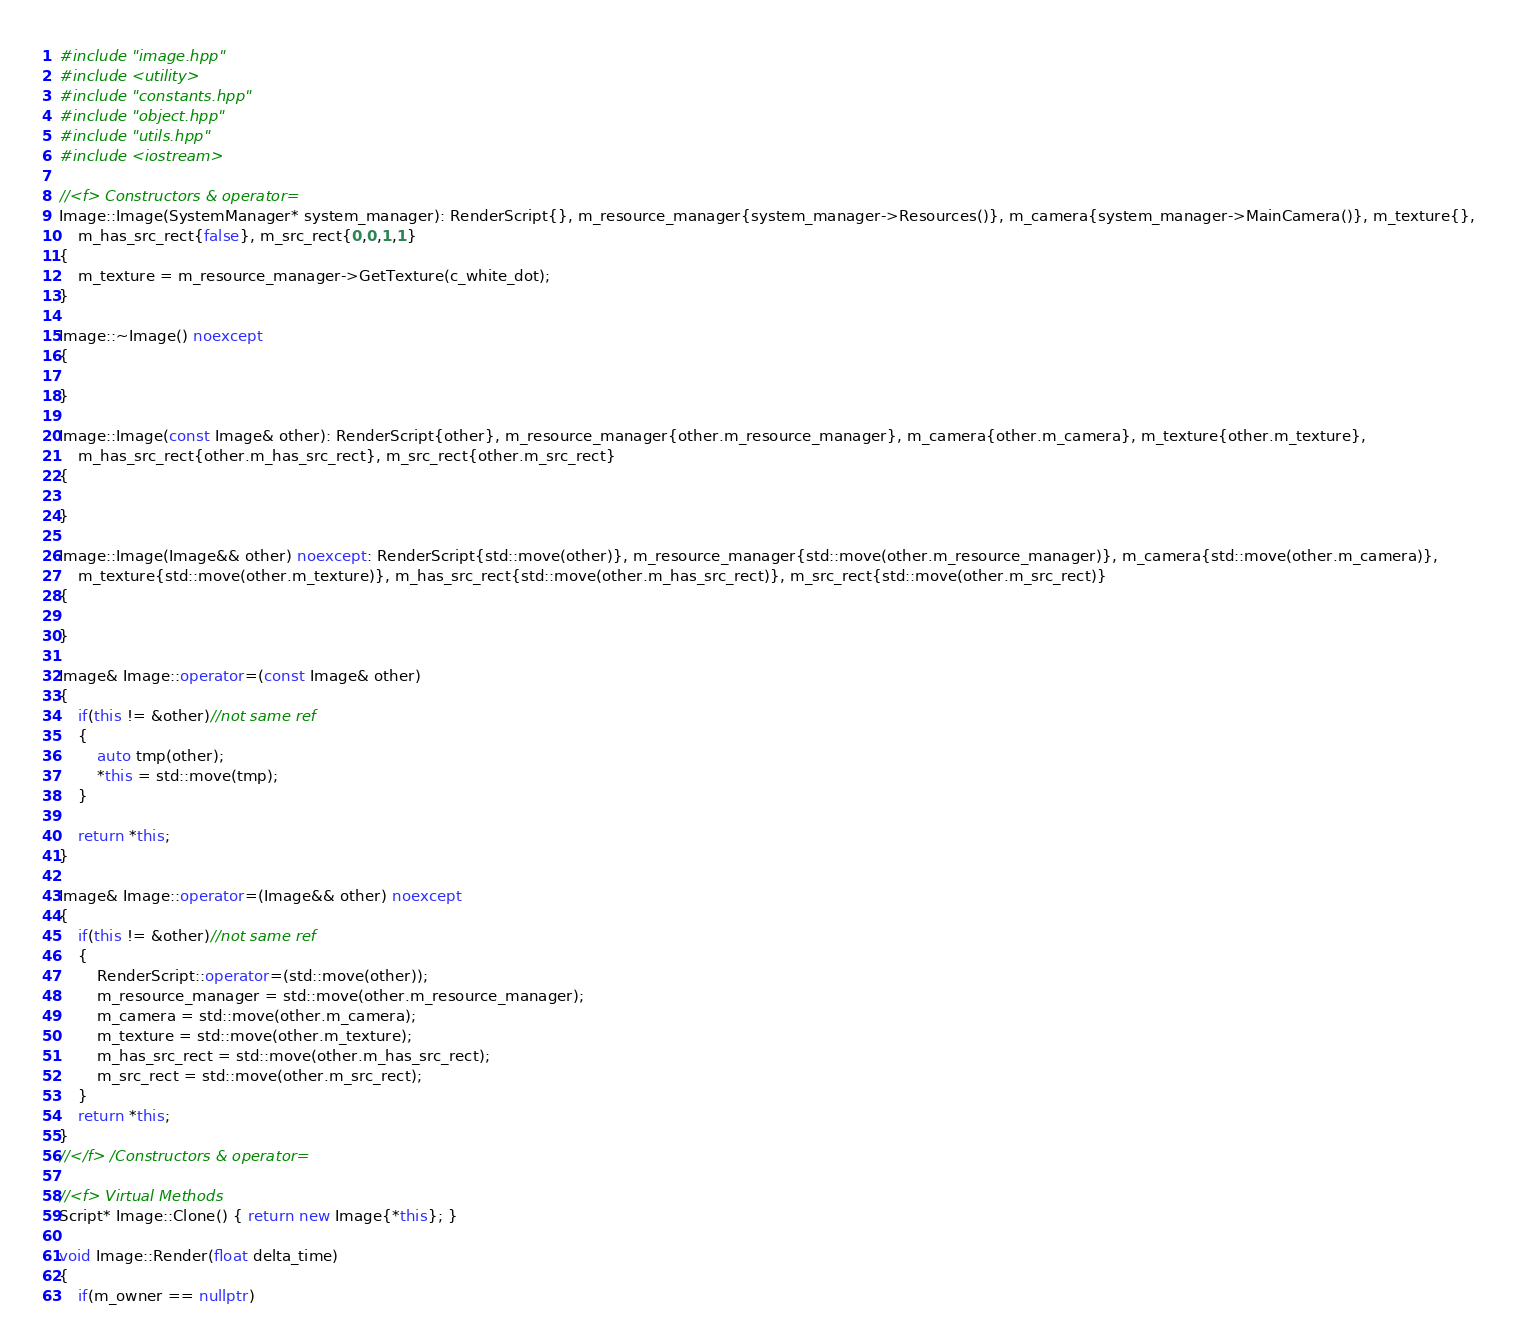Convert code to text. <code><loc_0><loc_0><loc_500><loc_500><_C++_>#include "image.hpp"
#include <utility>
#include "constants.hpp"
#include "object.hpp"
#include "utils.hpp"
#include <iostream>

//<f> Constructors & operator=
Image::Image(SystemManager* system_manager): RenderScript{}, m_resource_manager{system_manager->Resources()}, m_camera{system_manager->MainCamera()}, m_texture{},
    m_has_src_rect{false}, m_src_rect{0,0,1,1}
{
    m_texture = m_resource_manager->GetTexture(c_white_dot);
}

Image::~Image() noexcept
{

}

Image::Image(const Image& other): RenderScript{other}, m_resource_manager{other.m_resource_manager}, m_camera{other.m_camera}, m_texture{other.m_texture},
    m_has_src_rect{other.m_has_src_rect}, m_src_rect{other.m_src_rect}
{

}

Image::Image(Image&& other) noexcept: RenderScript{std::move(other)}, m_resource_manager{std::move(other.m_resource_manager)}, m_camera{std::move(other.m_camera)},
    m_texture{std::move(other.m_texture)}, m_has_src_rect{std::move(other.m_has_src_rect)}, m_src_rect{std::move(other.m_src_rect)}
{

}

Image& Image::operator=(const Image& other)
{
    if(this != &other)//not same ref
    {
        auto tmp(other);
        *this = std::move(tmp);
    }

    return *this;
}

Image& Image::operator=(Image&& other) noexcept
{
    if(this != &other)//not same ref
    {
        RenderScript::operator=(std::move(other));
        m_resource_manager = std::move(other.m_resource_manager);
        m_camera = std::move(other.m_camera);
        m_texture = std::move(other.m_texture);
        m_has_src_rect = std::move(other.m_has_src_rect);
        m_src_rect = std::move(other.m_src_rect);
    }
    return *this;
}
//</f> /Constructors & operator=

//<f> Virtual Methods
Script* Image::Clone() { return new Image{*this}; }

void Image::Render(float delta_time)
{
    if(m_owner == nullptr)</code> 